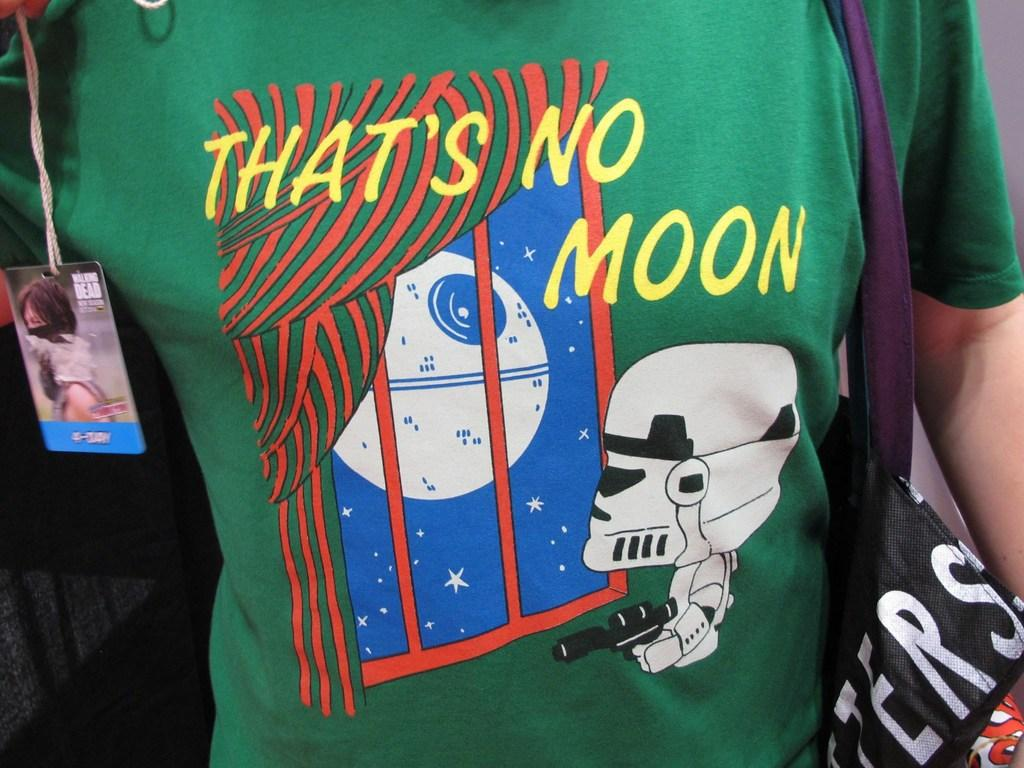<image>
Offer a succinct explanation of the picture presented. Storm Stormtrooper looking out of a window and see a big globe and thinks "That's no Moon." 